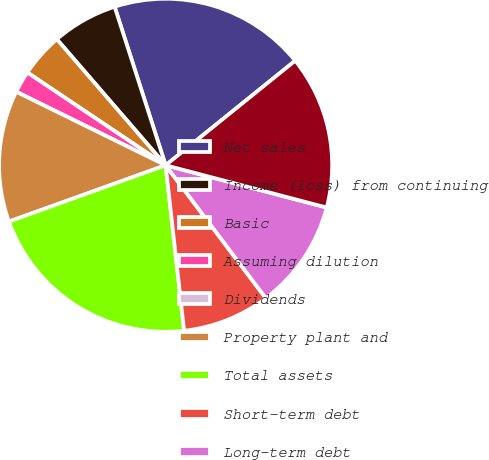<chart> <loc_0><loc_0><loc_500><loc_500><pie_chart><fcel>Net sales<fcel>Income (loss) from continuing<fcel>Basic<fcel>Assuming dilution<fcel>Dividends<fcel>Property plant and<fcel>Total assets<fcel>Short-term debt<fcel>Long-term debt<fcel>Total debt<nl><fcel>19.15%<fcel>6.38%<fcel>4.26%<fcel>2.13%<fcel>0.0%<fcel>12.77%<fcel>21.28%<fcel>8.51%<fcel>10.64%<fcel>14.89%<nl></chart> 